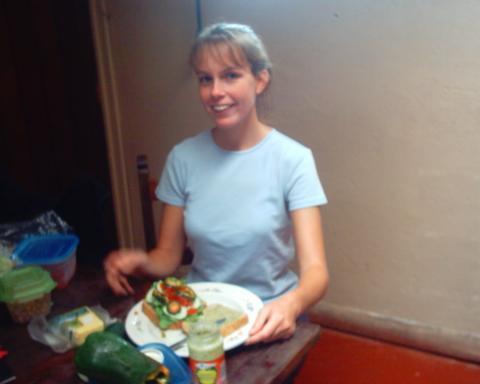How many dining tables are there?
Give a very brief answer. 2. How many cakes are on the table?
Give a very brief answer. 0. 